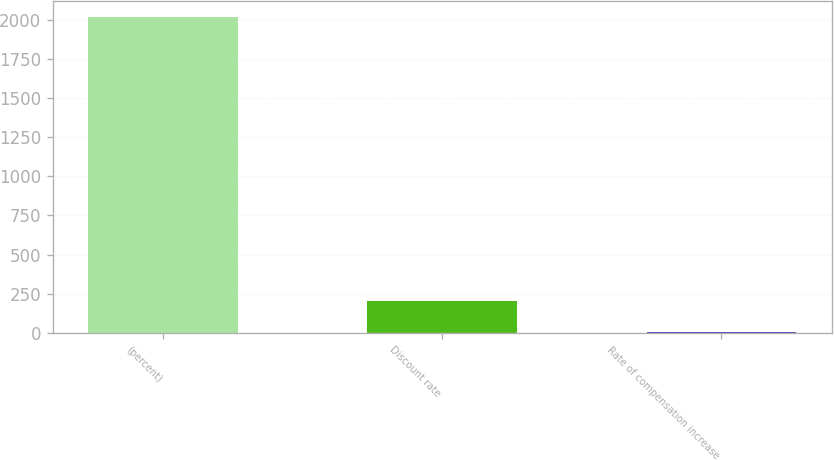Convert chart. <chart><loc_0><loc_0><loc_500><loc_500><bar_chart><fcel>(percent)<fcel>Discount rate<fcel>Rate of compensation increase<nl><fcel>2017<fcel>204.38<fcel>2.98<nl></chart> 